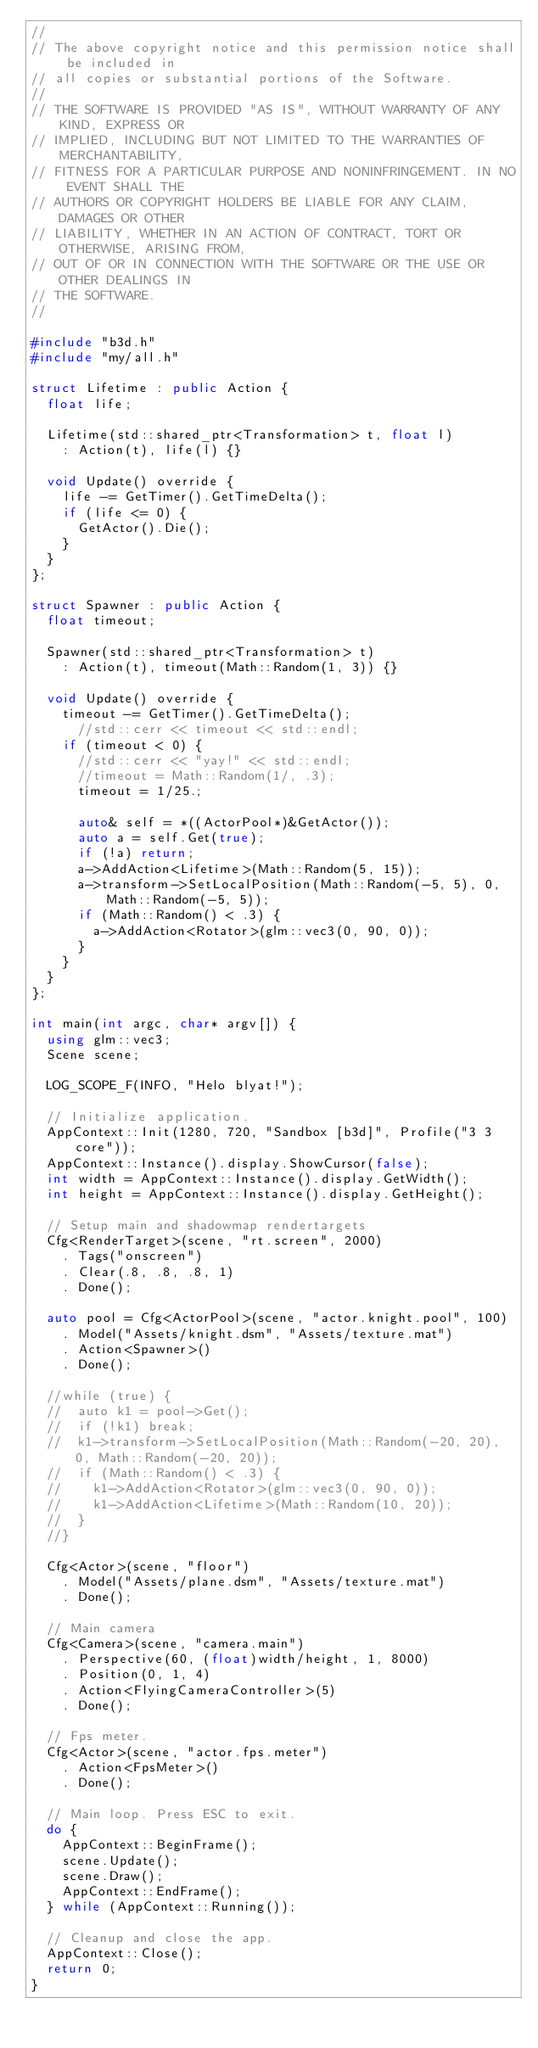<code> <loc_0><loc_0><loc_500><loc_500><_C++_>//
// The above copyright notice and this permission notice shall be included in
// all copies or substantial portions of the Software.
//
// THE SOFTWARE IS PROVIDED "AS IS", WITHOUT WARRANTY OF ANY KIND, EXPRESS OR
// IMPLIED, INCLUDING BUT NOT LIMITED TO THE WARRANTIES OF MERCHANTABILITY,
// FITNESS FOR A PARTICULAR PURPOSE AND NONINFRINGEMENT. IN NO EVENT SHALL THE
// AUTHORS OR COPYRIGHT HOLDERS BE LIABLE FOR ANY CLAIM, DAMAGES OR OTHER
// LIABILITY, WHETHER IN AN ACTION OF CONTRACT, TORT OR OTHERWISE, ARISING FROM,
// OUT OF OR IN CONNECTION WITH THE SOFTWARE OR THE USE OR OTHER DEALINGS IN
// THE SOFTWARE.
//

#include "b3d.h"
#include "my/all.h"

struct Lifetime : public Action {
  float life;

  Lifetime(std::shared_ptr<Transformation> t, float l)
    : Action(t), life(l) {}

  void Update() override {
    life -= GetTimer().GetTimeDelta();
    if (life <= 0) {
      GetActor().Die();
    }
  }
};

struct Spawner : public Action {
  float timeout;

  Spawner(std::shared_ptr<Transformation> t)
    : Action(t), timeout(Math::Random(1, 3)) {}

  void Update() override {
    timeout -= GetTimer().GetTimeDelta();
      //std::cerr << timeout << std::endl;
    if (timeout < 0) {
      //std::cerr << "yay!" << std::endl;
      //timeout = Math::Random(1/, .3);
      timeout = 1/25.;

      auto& self = *((ActorPool*)&GetActor());
      auto a = self.Get(true);
      if (!a) return;
      a->AddAction<Lifetime>(Math::Random(5, 15));
      a->transform->SetLocalPosition(Math::Random(-5, 5), 0, Math::Random(-5, 5));
      if (Math::Random() < .3) {
        a->AddAction<Rotator>(glm::vec3(0, 90, 0));
      }
    }
  }
};

int main(int argc, char* argv[]) {
  using glm::vec3;
  Scene scene;

  LOG_SCOPE_F(INFO, "Helo blyat!");

  // Initialize application.
  AppContext::Init(1280, 720, "Sandbox [b3d]", Profile("3 3 core"));
  AppContext::Instance().display.ShowCursor(false);
  int width = AppContext::Instance().display.GetWidth();
  int height = AppContext::Instance().display.GetHeight();

  // Setup main and shadowmap rendertargets
  Cfg<RenderTarget>(scene, "rt.screen", 2000)
    . Tags("onscreen")
    . Clear(.8, .8, .8, 1)
    . Done();
  
  auto pool = Cfg<ActorPool>(scene, "actor.knight.pool", 100)
    . Model("Assets/knight.dsm", "Assets/texture.mat")
    . Action<Spawner>()
    . Done();

  //while (true) {
  //  auto k1 = pool->Get(); 
  //  if (!k1) break;
  //  k1->transform->SetLocalPosition(Math::Random(-20, 20), 0, Math::Random(-20, 20));
  //  if (Math::Random() < .3) {
  //    k1->AddAction<Rotator>(glm::vec3(0, 90, 0));
  //    k1->AddAction<Lifetime>(Math::Random(10, 20));
  //  }
  //}

  Cfg<Actor>(scene, "floor")
    . Model("Assets/plane.dsm", "Assets/texture.mat")
    . Done();

  // Main camera
  Cfg<Camera>(scene, "camera.main")
    . Perspective(60, (float)width/height, 1, 8000) 
    . Position(0, 1, 4)
    . Action<FlyingCameraController>(5)
    . Done();
  
  // Fps meter.
  Cfg<Actor>(scene, "actor.fps.meter")
    . Action<FpsMeter>()
    . Done();
  
  // Main loop. Press ESC to exit.
  do {
    AppContext::BeginFrame();
    scene.Update();
    scene.Draw();
    AppContext::EndFrame();
  } while (AppContext::Running());

  // Cleanup and close the app.
  AppContext::Close();
  return 0;
}
</code> 